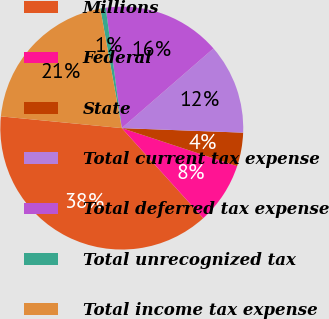<chart> <loc_0><loc_0><loc_500><loc_500><pie_chart><fcel>Millions<fcel>Federal<fcel>State<fcel>Total current tax expense<fcel>Total deferred tax expense<fcel>Total unrecognized tax<fcel>Total income tax expense<nl><fcel>38.24%<fcel>8.23%<fcel>4.47%<fcel>11.98%<fcel>15.73%<fcel>0.72%<fcel>20.63%<nl></chart> 